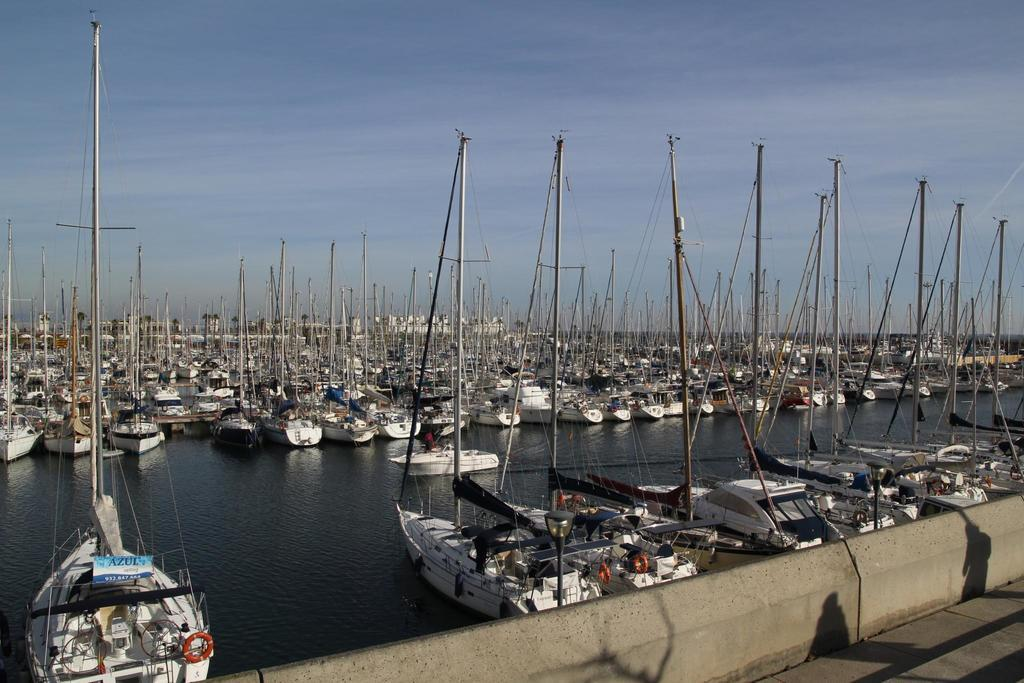Where was the image taken? The image was taken in a shipyard. What can be seen in the foreground of the image? There is a dock in the foreground of the image. What is the main feature in the center of the image? There is a water body in the center of the image. How many boats are visible in the water? There are many boats in the water. What is visible at the top of the image? The sky is visible at the top of the image. What type of attraction can be seen in the water in the image? There is no attraction present in the water in the image; it features a water body with boats. What color is the paint on the boats in the image? The provided facts do not mention the color of the paint on the boats, so it cannot be determined from the image. 